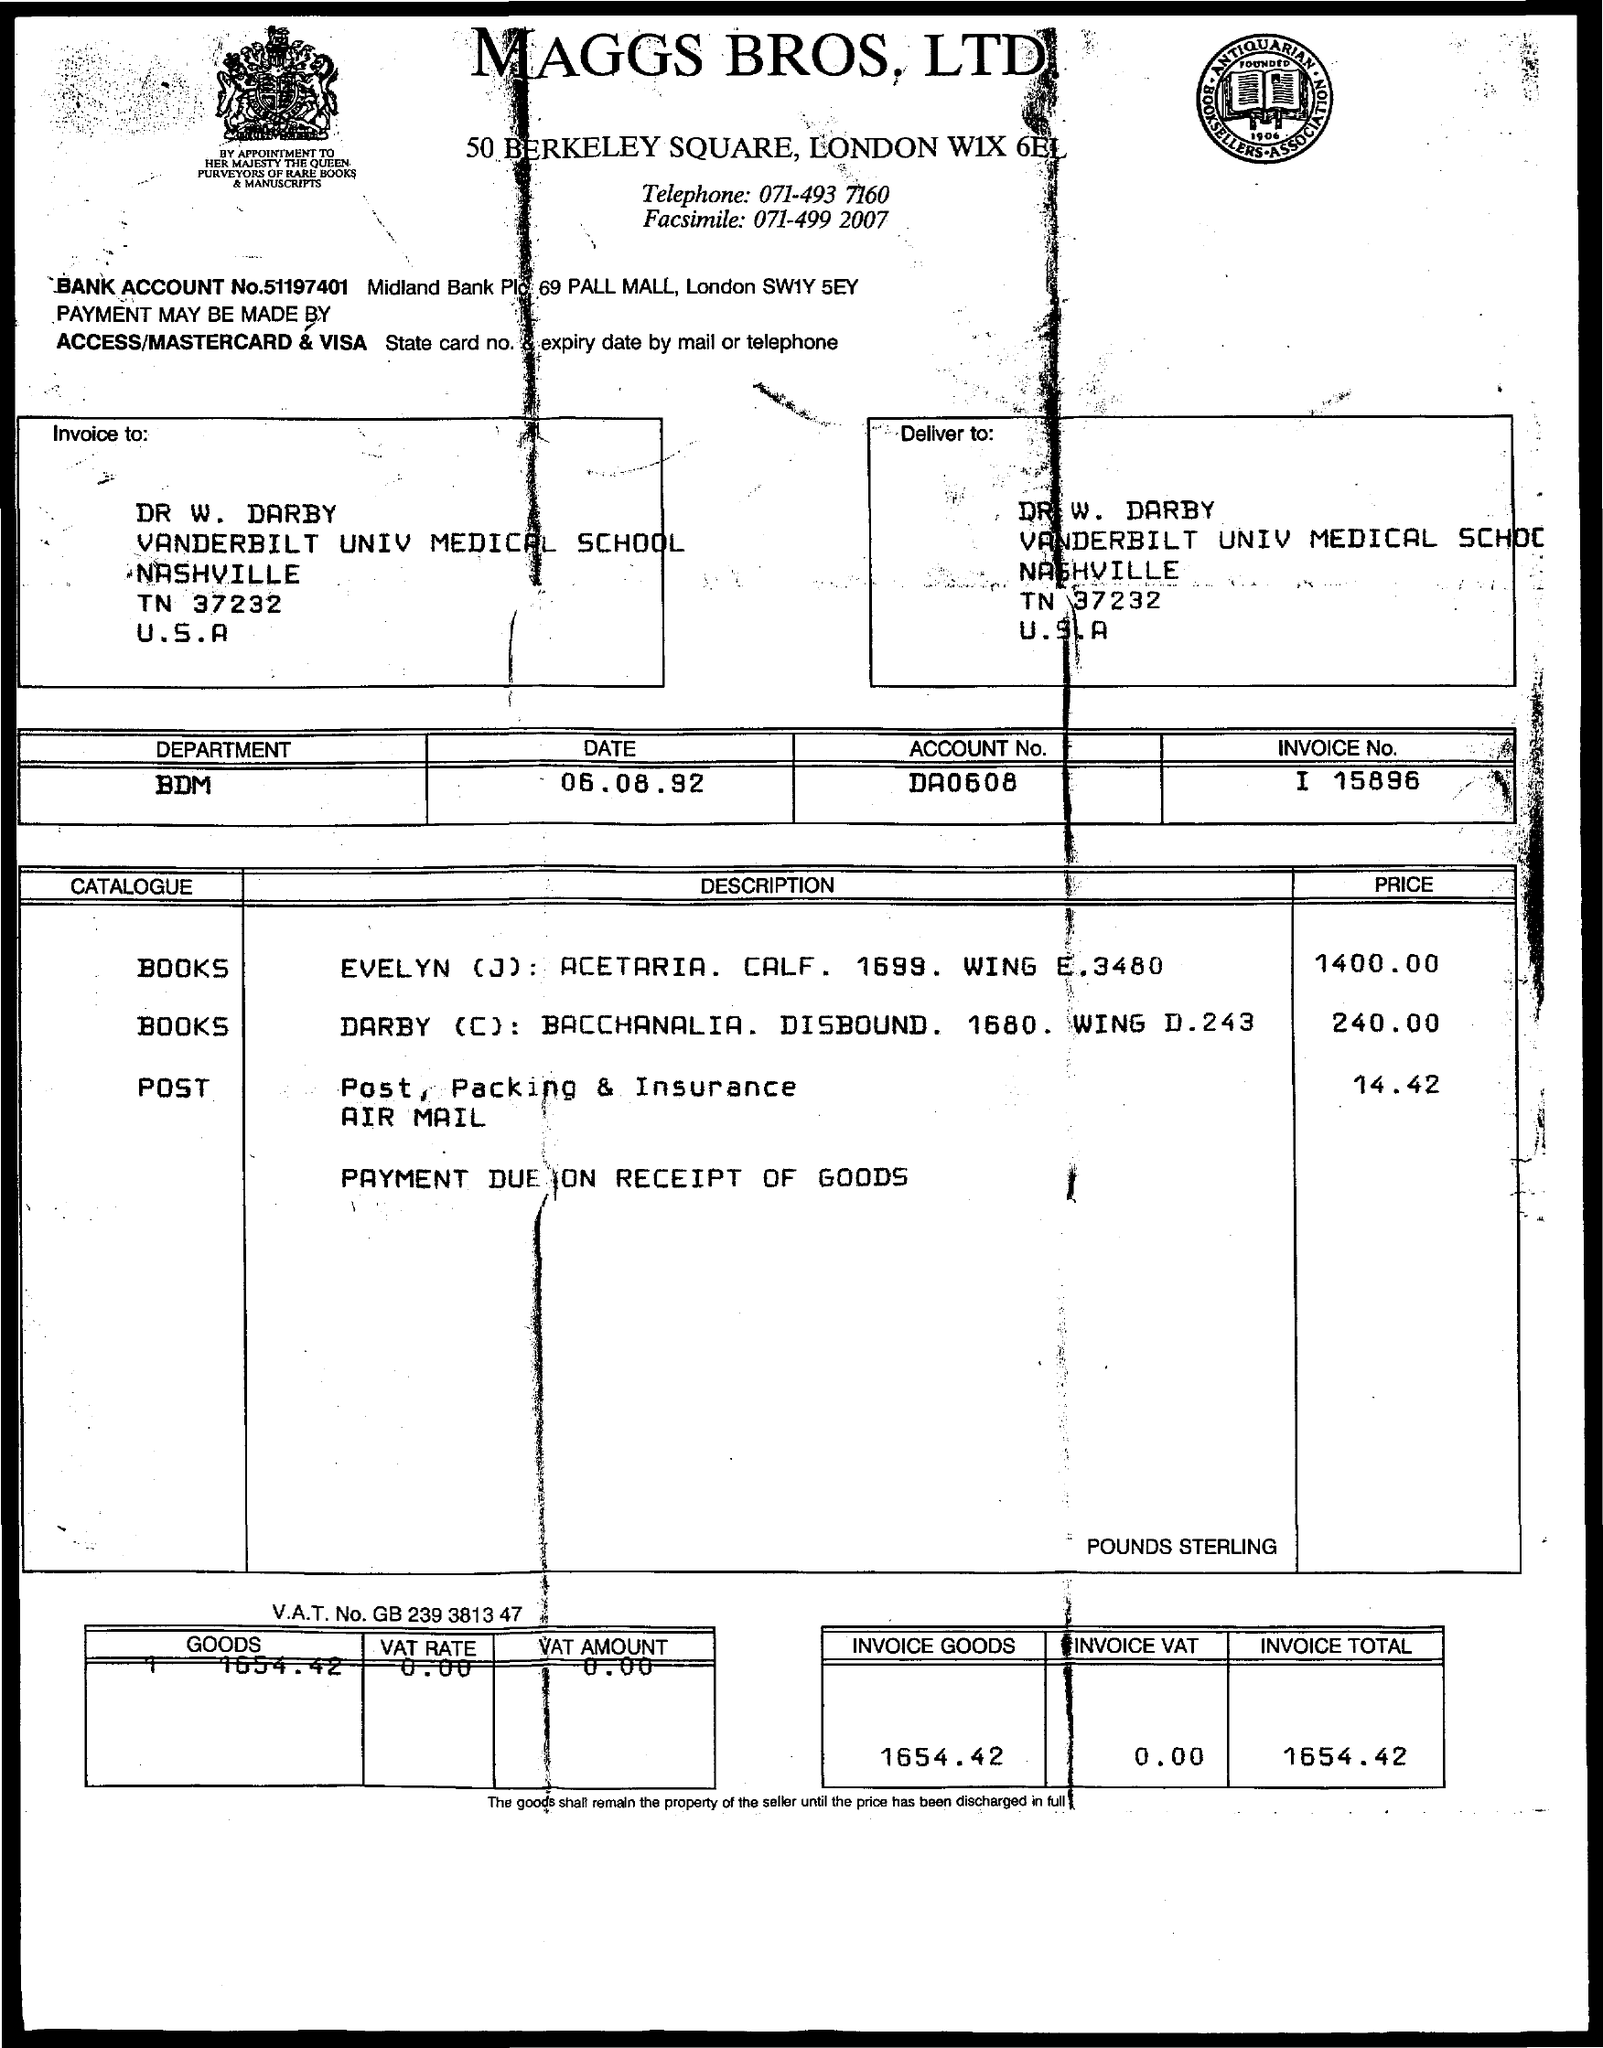Specify some key components in this picture. The date referenced in the document is 06.08.92. The title of the document from Maggs Bros. Ltd. is [insert title here]. The invoice number is 15896. The invoice total is 1654.42. The price of the post is 14.42. 